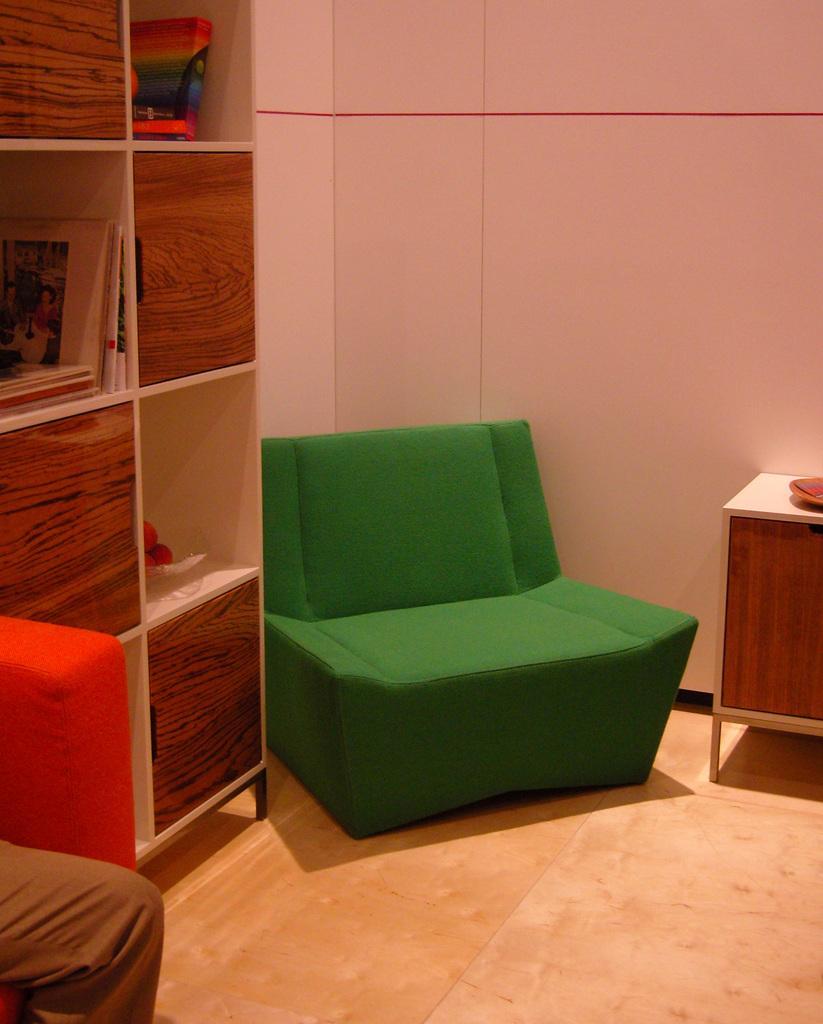Can you describe this image briefly? In the given image we can find human,sofa cupboards and a table. 